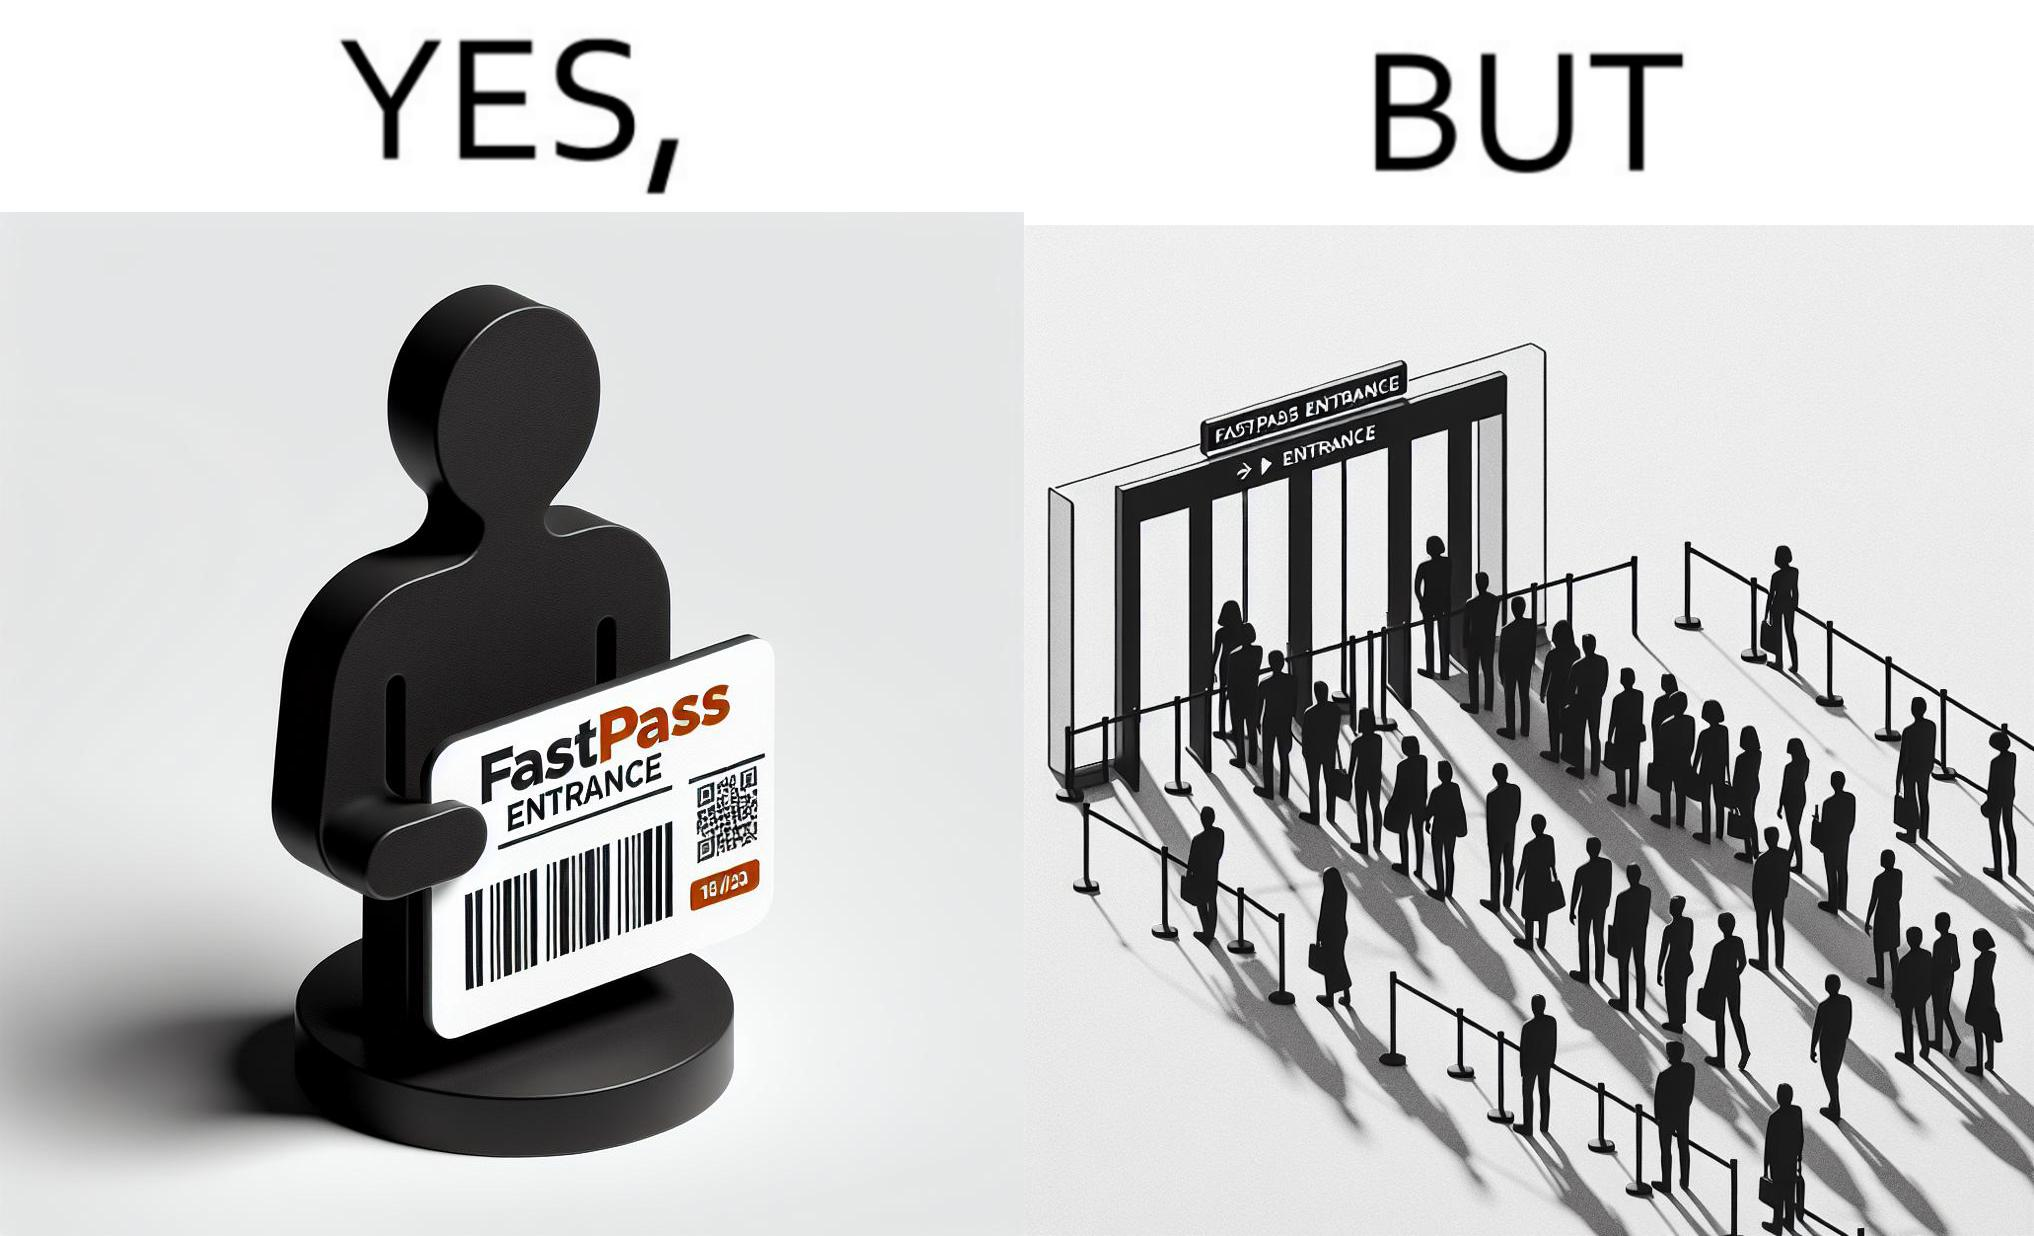Is there satirical content in this image? Yes, this image is satirical. 